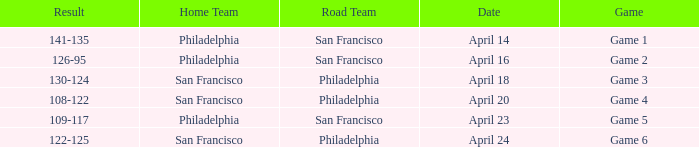Which game had a result of 126-95? Game 2. 